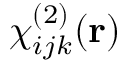Convert formula to latex. <formula><loc_0><loc_0><loc_500><loc_500>\chi _ { i j k } ^ { ( 2 ) } ( r )</formula> 